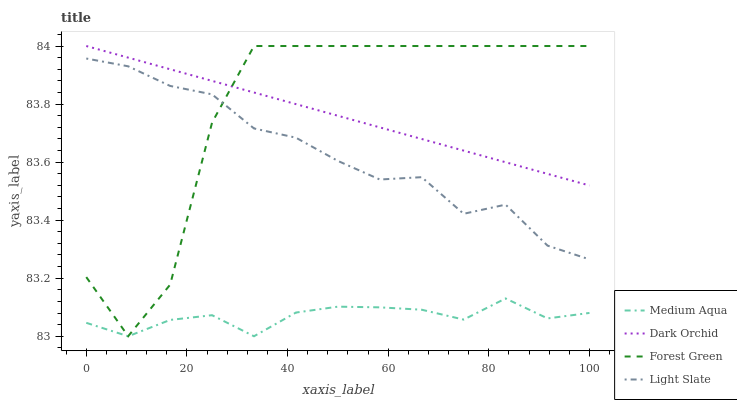Does Medium Aqua have the minimum area under the curve?
Answer yes or no. Yes. Does Forest Green have the maximum area under the curve?
Answer yes or no. Yes. Does Forest Green have the minimum area under the curve?
Answer yes or no. No. Does Medium Aqua have the maximum area under the curve?
Answer yes or no. No. Is Dark Orchid the smoothest?
Answer yes or no. Yes. Is Forest Green the roughest?
Answer yes or no. Yes. Is Medium Aqua the smoothest?
Answer yes or no. No. Is Medium Aqua the roughest?
Answer yes or no. No. Does Medium Aqua have the lowest value?
Answer yes or no. Yes. Does Forest Green have the lowest value?
Answer yes or no. No. Does Dark Orchid have the highest value?
Answer yes or no. Yes. Does Medium Aqua have the highest value?
Answer yes or no. No. Is Medium Aqua less than Dark Orchid?
Answer yes or no. Yes. Is Dark Orchid greater than Medium Aqua?
Answer yes or no. Yes. Does Dark Orchid intersect Forest Green?
Answer yes or no. Yes. Is Dark Orchid less than Forest Green?
Answer yes or no. No. Is Dark Orchid greater than Forest Green?
Answer yes or no. No. Does Medium Aqua intersect Dark Orchid?
Answer yes or no. No. 